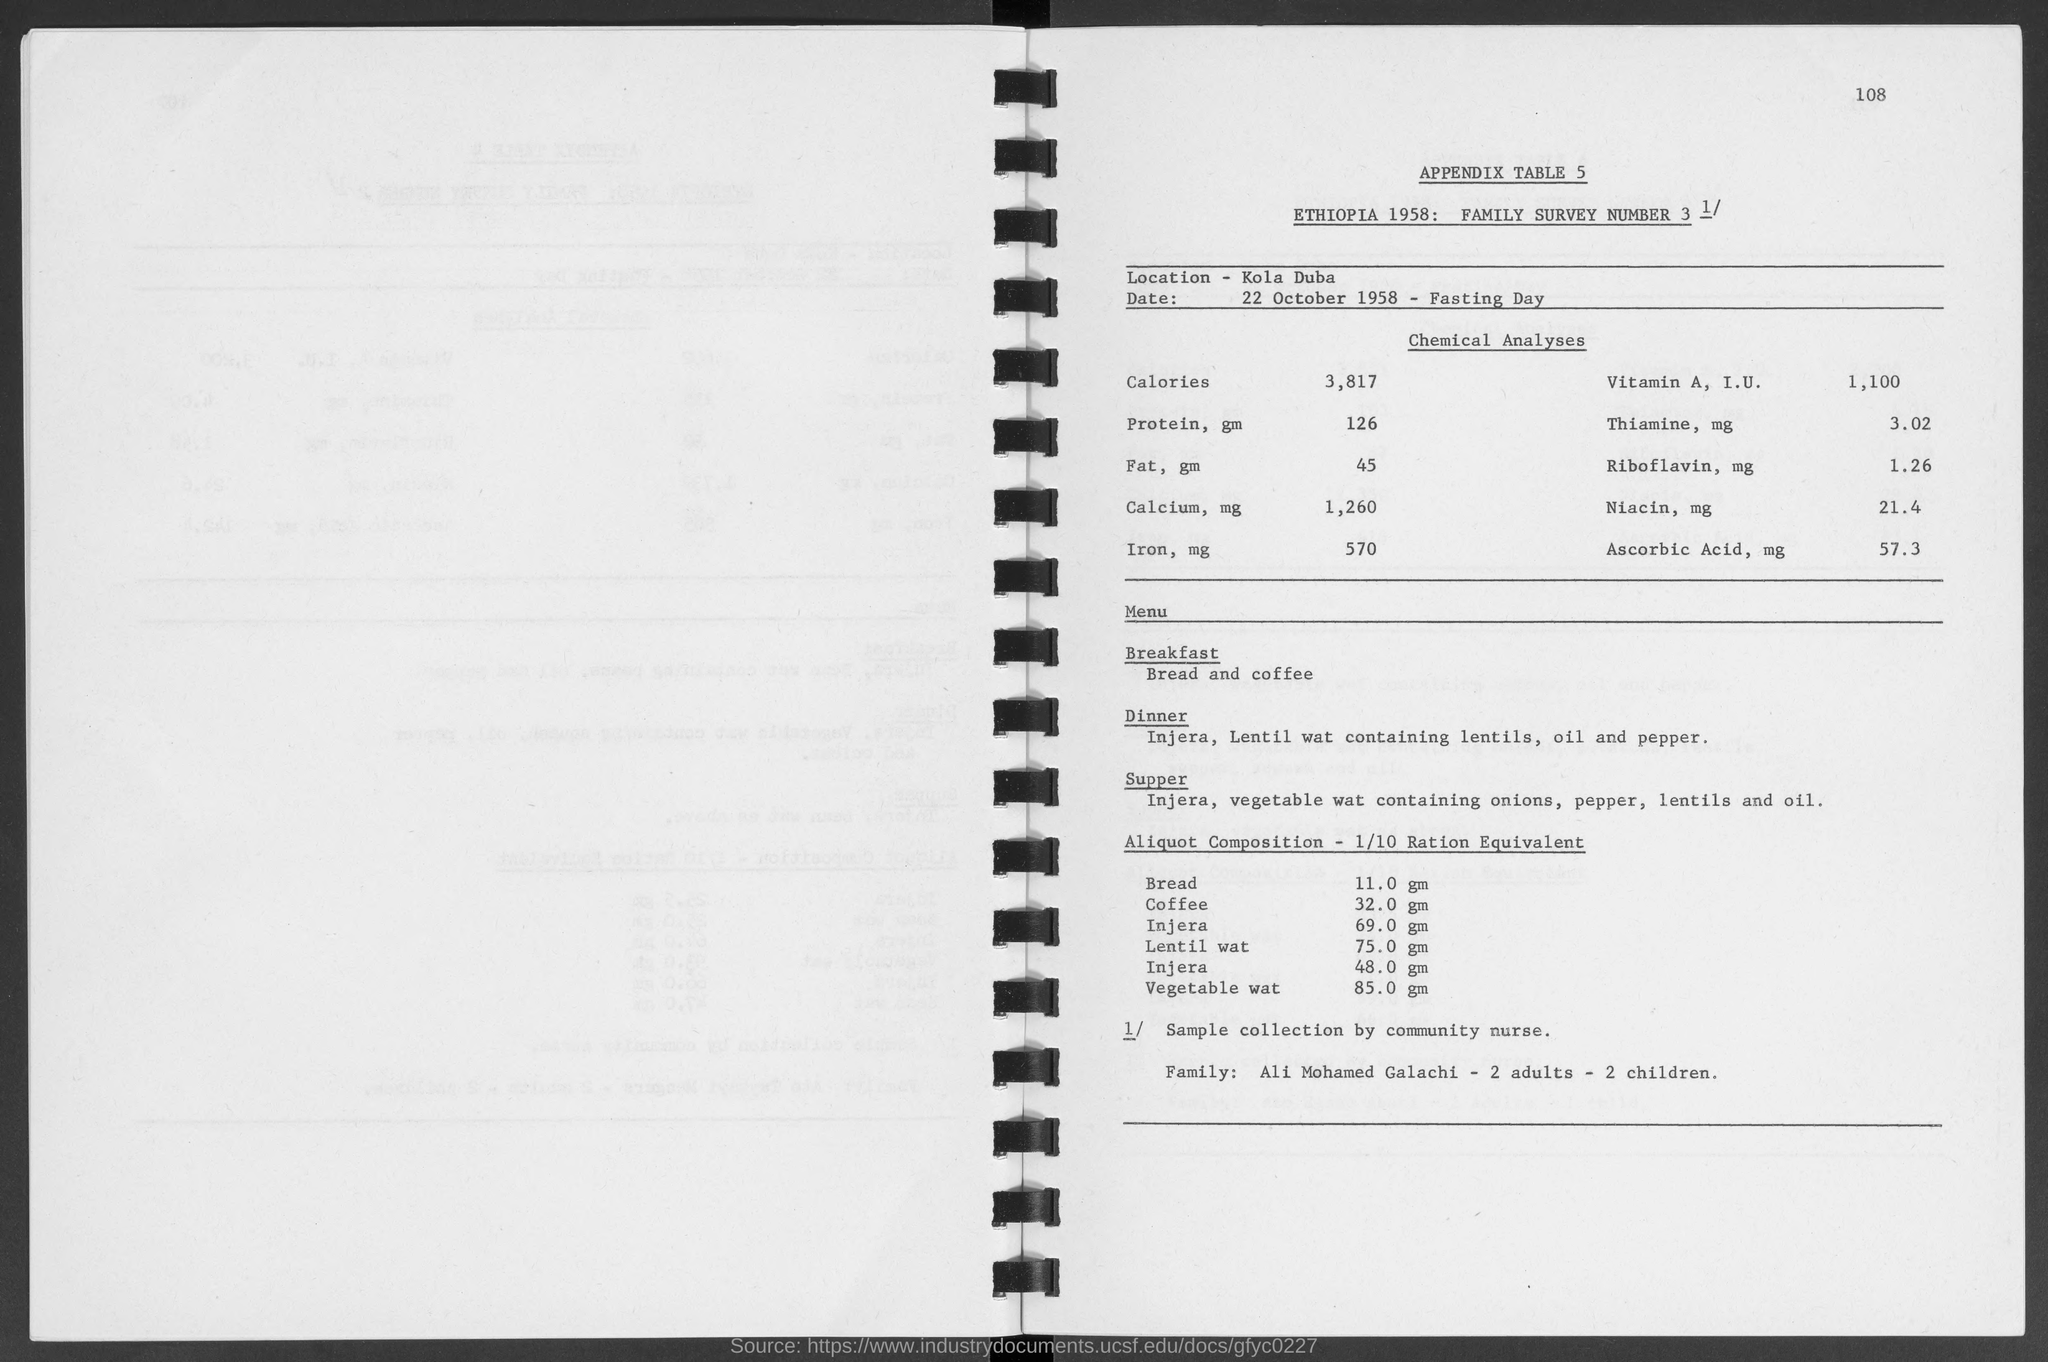Point out several critical features in this image. On October 22, 1958, the date for fasting day is. The number located in the top-right corner of the page is 108. The location is Kola Duba. 